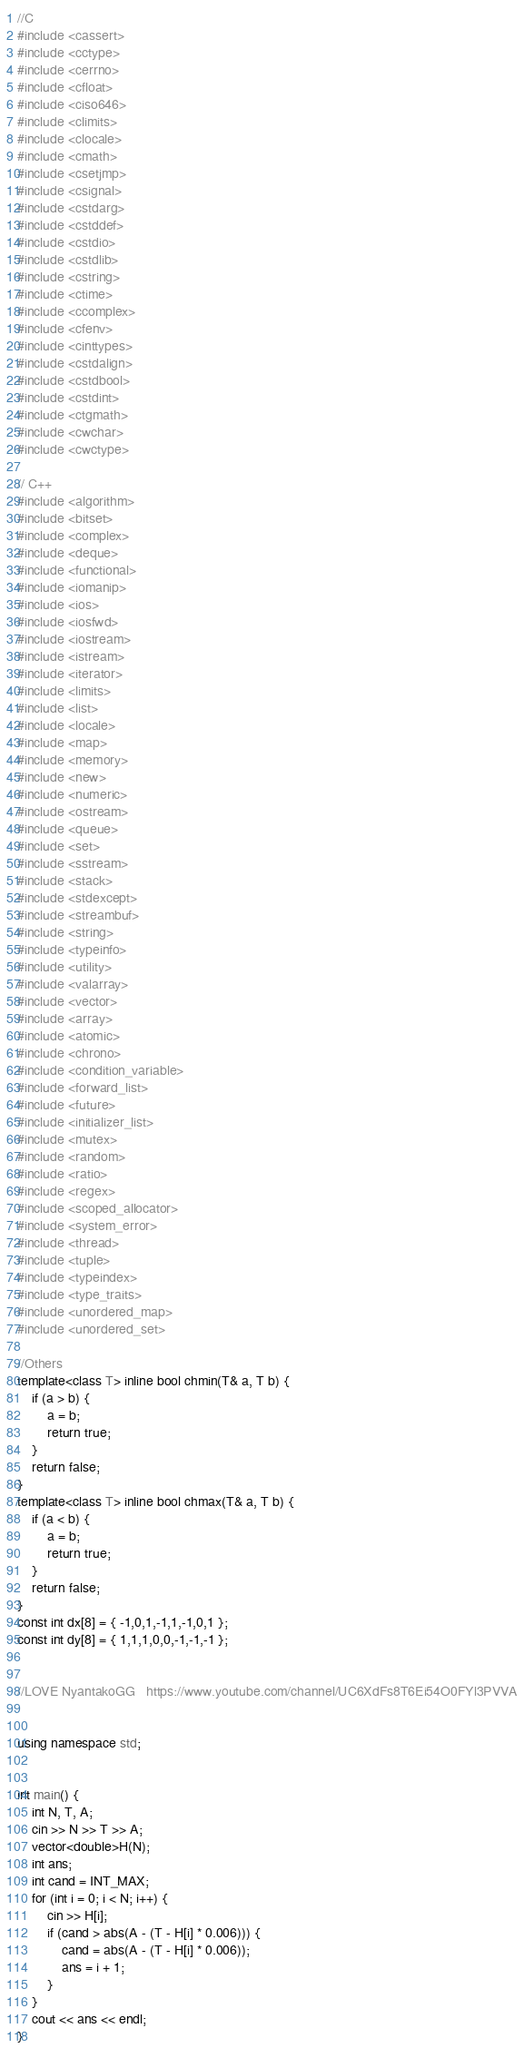<code> <loc_0><loc_0><loc_500><loc_500><_C++_>//C
#include <cassert>
#include <cctype>
#include <cerrno>
#include <cfloat>
#include <ciso646>
#include <climits>
#include <clocale>
#include <cmath>
#include <csetjmp>
#include <csignal>
#include <cstdarg>
#include <cstddef>
#include <cstdio>
#include <cstdlib>
#include <cstring>
#include <ctime>
#include <ccomplex>
#include <cfenv>
#include <cinttypes>
#include <cstdalign>
#include <cstdbool>
#include <cstdint>
#include <ctgmath>
#include <cwchar>
#include <cwctype>

// C++
#include <algorithm>
#include <bitset>
#include <complex>
#include <deque>
#include <functional>
#include <iomanip>
#include <ios>
#include <iosfwd>
#include <iostream>
#include <istream>
#include <iterator>
#include <limits>
#include <list>
#include <locale>
#include <map>
#include <memory>
#include <new>
#include <numeric>
#include <ostream>
#include <queue>
#include <set>
#include <sstream>
#include <stack>
#include <stdexcept>
#include <streambuf>
#include <string>
#include <typeinfo>
#include <utility>
#include <valarray>
#include <vector>
#include <array>
#include <atomic>
#include <chrono>
#include <condition_variable>
#include <forward_list>
#include <future>
#include <initializer_list>
#include <mutex>
#include <random>
#include <ratio>
#include <regex>
#include <scoped_allocator>
#include <system_error>
#include <thread>
#include <tuple>
#include <typeindex>
#include <type_traits>
#include <unordered_map>
#include <unordered_set>

//Others
template<class T> inline bool chmin(T& a, T b) {
	if (a > b) {
		a = b;
		return true;
	}
	return false;
}
template<class T> inline bool chmax(T& a, T b) {
	if (a < b) {
		a = b;
		return true;
	}
	return false;
}
const int dx[8] = { -1,0,1,-1,1,-1,0,1 };
const int dy[8] = { 1,1,1,0,0,-1,-1,-1 };


//LOVE NyantakoGG	https://www.youtube.com/channel/UC6XdFs8T6Ei54O0FYl3PVVA


using namespace std;


int main() {
	int N, T, A;
	cin >> N >> T >> A;
	vector<double>H(N);
	int ans;
	int cand = INT_MAX;
	for (int i = 0; i < N; i++) {
		cin >> H[i];
		if (cand > abs(A - (T - H[i] * 0.006))) {
			cand = abs(A - (T - H[i] * 0.006));
			ans = i + 1;
		}
	}
	cout << ans << endl;
}
</code> 